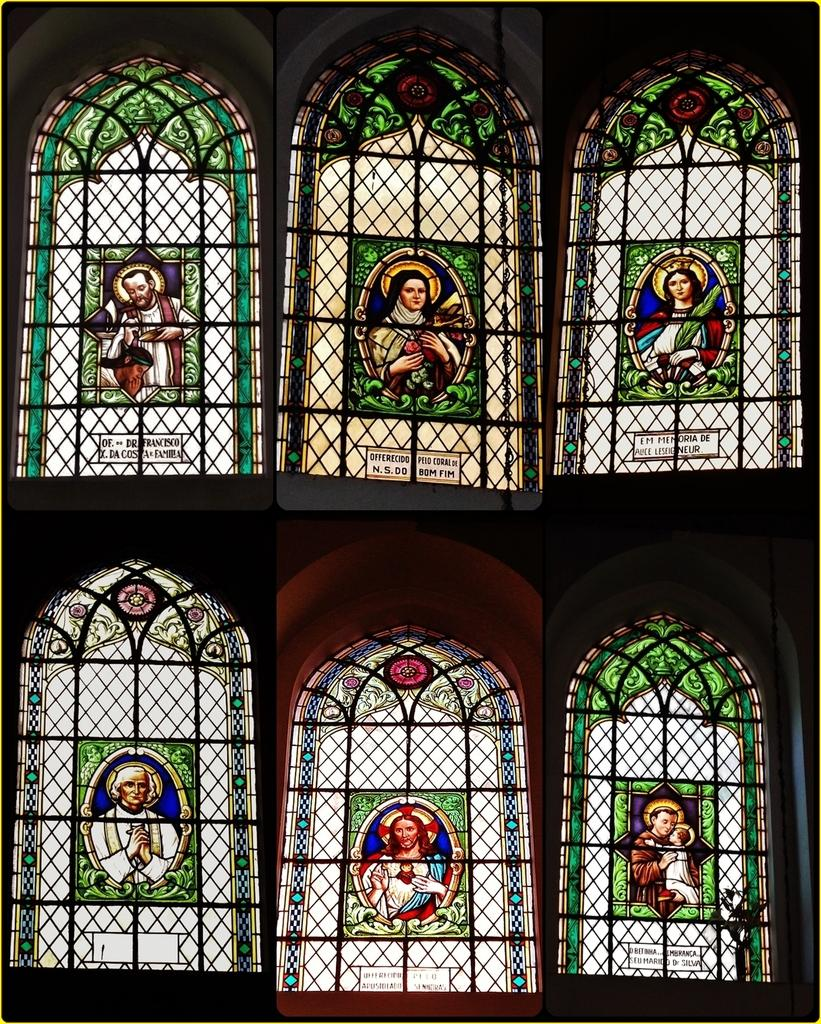What type of accessory is featured in the image? There are designer glasses in the image. Where are the designer glasses located? The designer glasses are placed near windows. What is depicted on the glasses? There are pictures of men and women on the glasses. Are there any words or phrases on the glasses? Yes, there is text on the glasses. Can you see any blood on the glasses in the image? No, there is no blood present on the glasses in the image. Are there any bears depicted on the glasses? No, there are no bears depicted on the glasses; they feature pictures of men and women. 